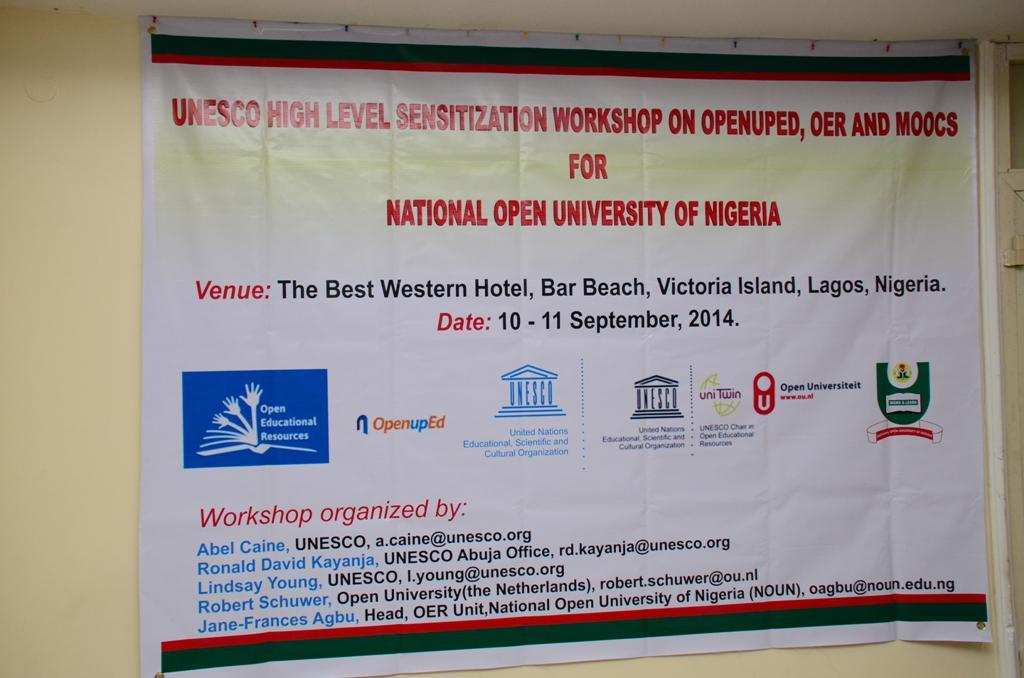Provide a one-sentence caption for the provided image. A poster for a Senzitization Workshop of the National Open University of Nigeria. 